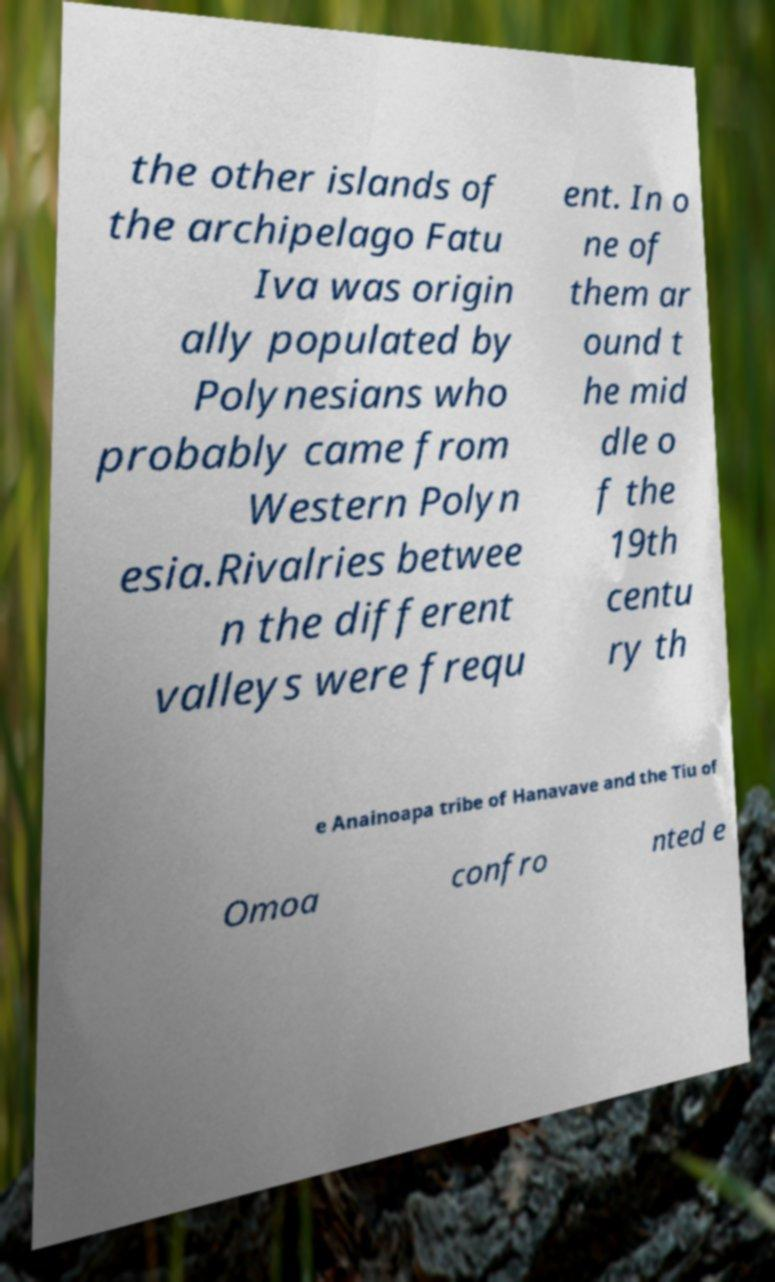Can you accurately transcribe the text from the provided image for me? the other islands of the archipelago Fatu Iva was origin ally populated by Polynesians who probably came from Western Polyn esia.Rivalries betwee n the different valleys were frequ ent. In o ne of them ar ound t he mid dle o f the 19th centu ry th e Anainoapa tribe of Hanavave and the Tiu of Omoa confro nted e 